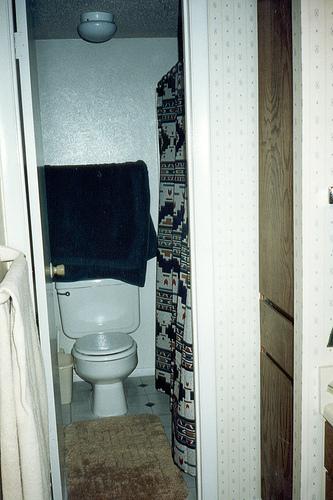What is on the floor in front of the toilet?
Concise answer only. Rug. Is this picture of a bathroom?
Answer briefly. Yes. What are the colors of the shower curtain?
Quick response, please. Black and white. 